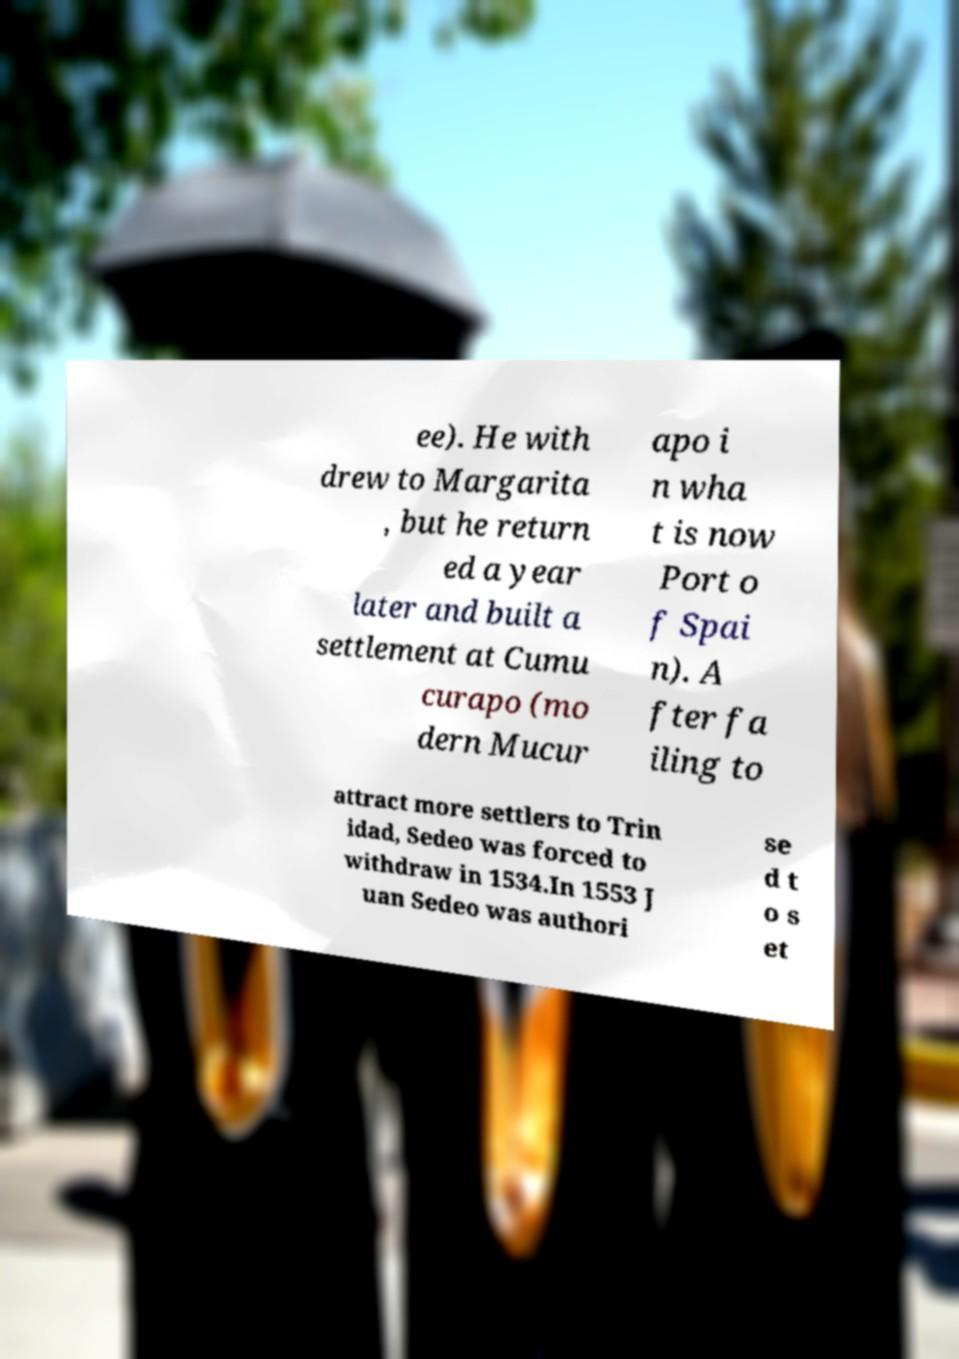What messages or text are displayed in this image? I need them in a readable, typed format. ee). He with drew to Margarita , but he return ed a year later and built a settlement at Cumu curapo (mo dern Mucur apo i n wha t is now Port o f Spai n). A fter fa iling to attract more settlers to Trin idad, Sedeo was forced to withdraw in 1534.In 1553 J uan Sedeo was authori se d t o s et 